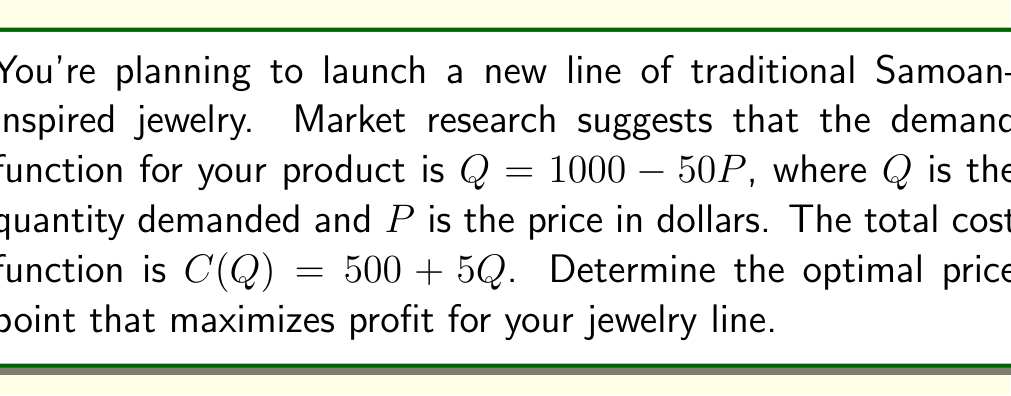What is the answer to this math problem? To find the optimal price point, we need to follow these steps:

1. Find the revenue function:
   $R = PQ = P(1000 - 50P) = 1000P - 50P^2$

2. Find the marginal revenue function by differentiating R with respect to P:
   $MR = \frac{dR}{dP} = 1000 - 100P$

3. Find the marginal cost function:
   $MC = \frac{dC}{dQ} = 5$

4. Set marginal revenue equal to marginal cost:
   $1000 - 100P = 5$

5. Solve for P:
   $-100P = -995$
   $P = 9.95$

6. Verify that this is a maximum by checking the second derivative of the profit function:
   Profit function: $\pi = R - C = (1000P - 50P^2) - (500 + 5(1000 - 50P))$
   $\frac{d^2\pi}{dP^2} = -100$, which is negative, confirming a maximum.

7. Calculate the quantity at this price:
   $Q = 1000 - 50(9.95) = 502.5$

8. Round the price to the nearest cent for practicality:
   $P = $9.95$

Therefore, the optimal price point that maximizes profit is $9.95 per piece of jewelry.
Answer: $9.95 